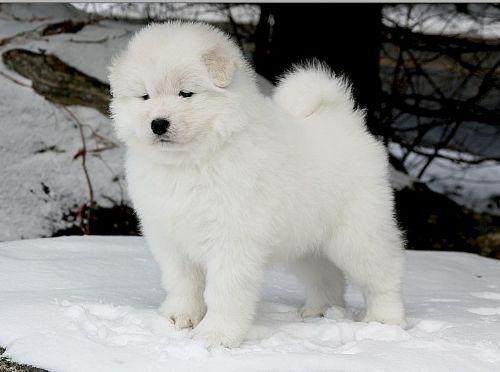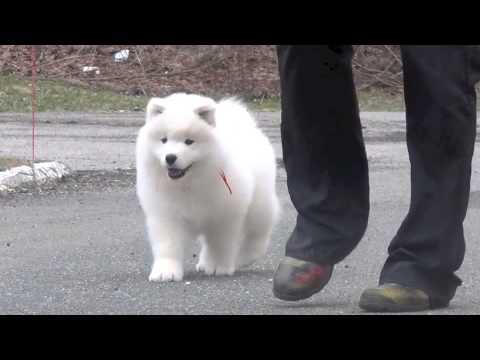The first image is the image on the left, the second image is the image on the right. Assess this claim about the two images: "At least one white dog is standing next to a person's legs.". Correct or not? Answer yes or no. Yes. The first image is the image on the left, the second image is the image on the right. Considering the images on both sides, is "There are five white and fluffy dogs including a single dog sitting." valid? Answer yes or no. No. 